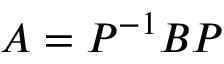Convert formula to latex. <formula><loc_0><loc_0><loc_500><loc_500>A = P ^ { - 1 } B P</formula> 